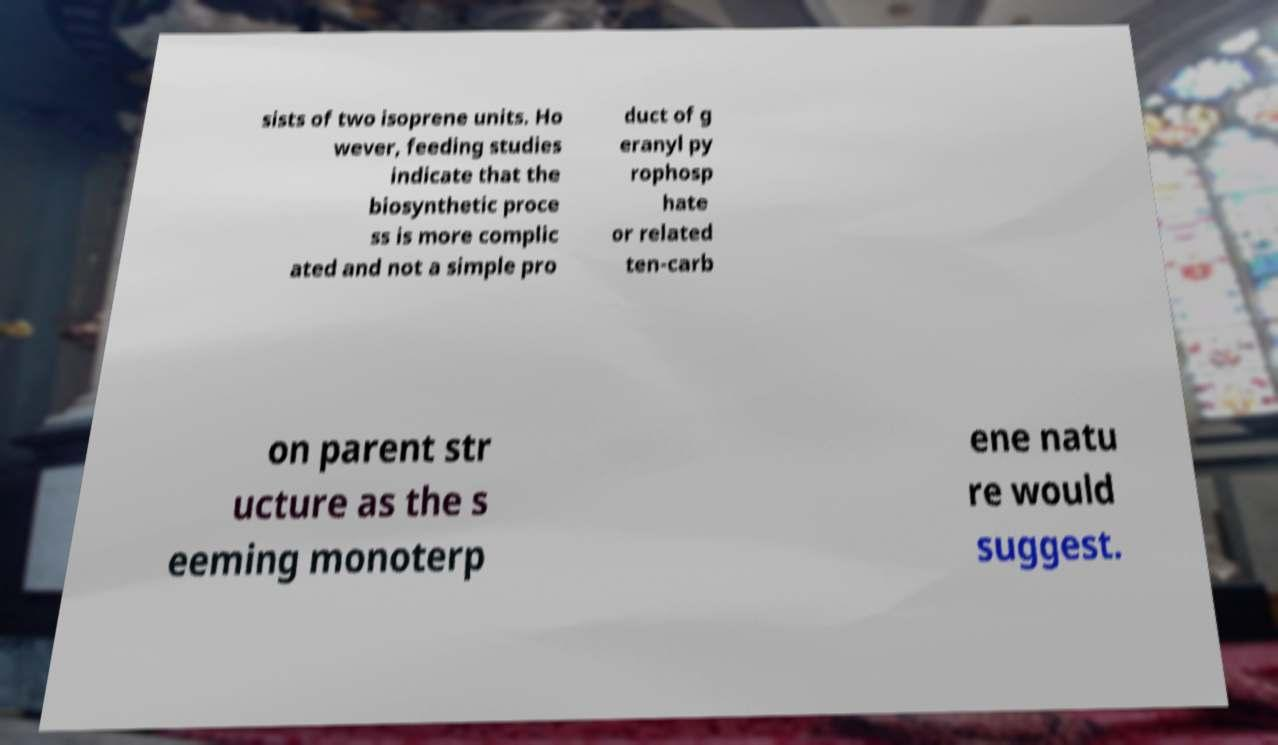Could you extract and type out the text from this image? sists of two isoprene units. Ho wever, feeding studies indicate that the biosynthetic proce ss is more complic ated and not a simple pro duct of g eranyl py rophosp hate or related ten-carb on parent str ucture as the s eeming monoterp ene natu re would suggest. 